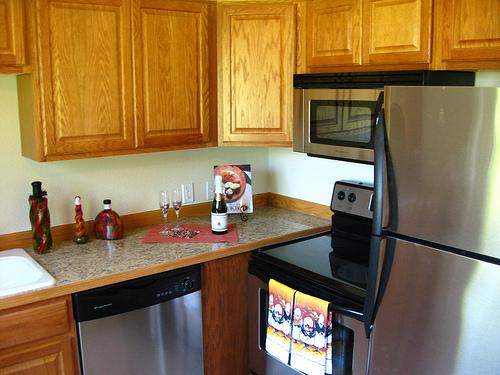Question: why are there towels?
Choices:
A. For decoration.
B. For wiping off hands.
C. For drying off face.
D. For drying off body.
Answer with the letter. Answer: B Question: what color is the sink?
Choices:
A. White.
B. Green.
C. Red.
D. Blue.
Answer with the letter. Answer: A 